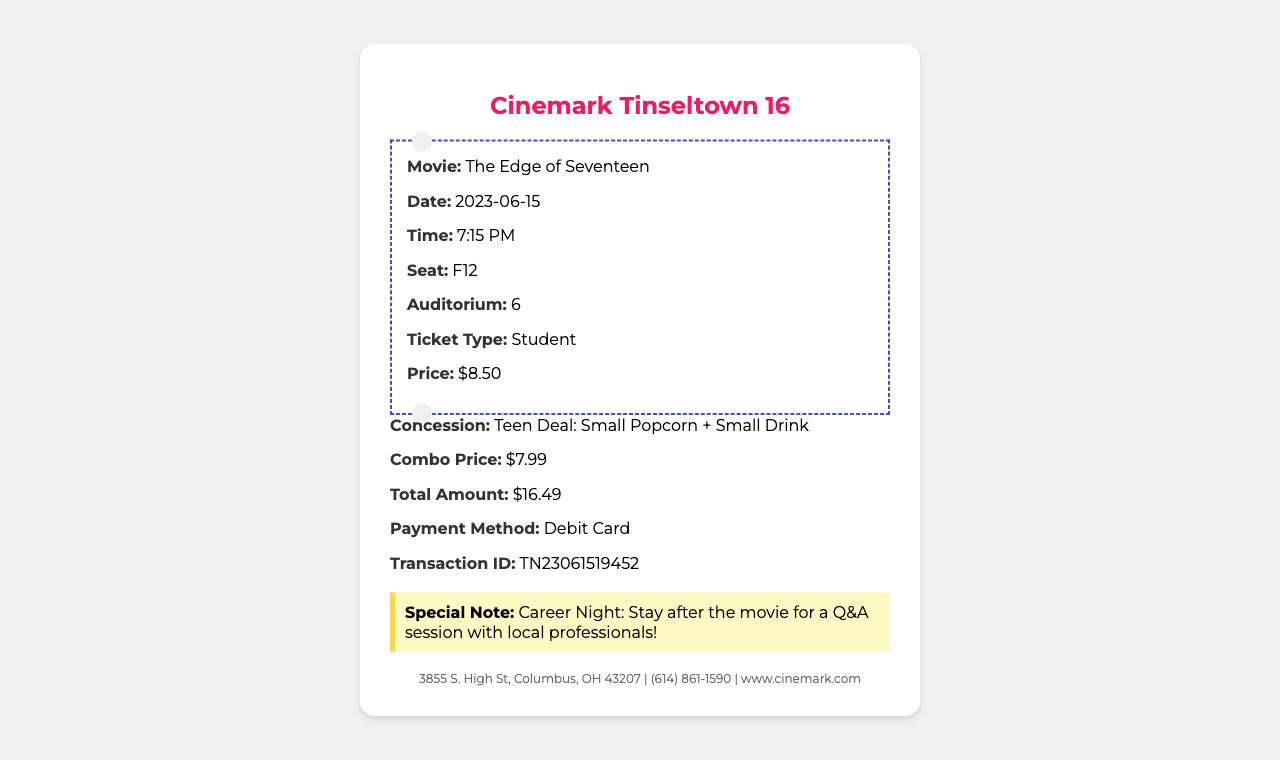what is the movie title? The movie title is explicitly mentioned in the document as the main focus of the ticket receipt.
Answer: The Edge of Seventeen what is the show date? The show date indicates when the movie is scheduled to be screened, as shown on the receipt.
Answer: 2023-06-15 what is the seat number? The seat number specifies where the ticket holder will sit in the auditorium, which is listed on the receipt.
Answer: F12 what is the ticket price? The ticket price is stated as the cost for the selected ticket type on the receipt.
Answer: $8.50 what is the total amount paid? The total amount represents the sum of all costs incurred in the transaction, shown at the bottom of the receipt.
Answer: $16.49 how many rewards points were earned? The rewards points earned are specified in the receipt, showing the benefits of the transaction.
Answer: 165 who is the cashier? The name of the cashier is provided on the receipt, indicating who processed the transaction.
Answer: Emma what type of special event is mentioned? The special note points to an event related to career exploration, which adds significance to the movie experience.
Answer: Career Night what is the runtime of the movie? The runtime informs viewers how long the movie will last and is included in the details on the receipt.
Answer: 104 minutes what is the concession deal indicated? The concession deal outlines a specific combination of snacks and drinks available at a discounted rate, which can enhance the movie experience.
Answer: Teen Deal: Small Popcorn + Small Drink 